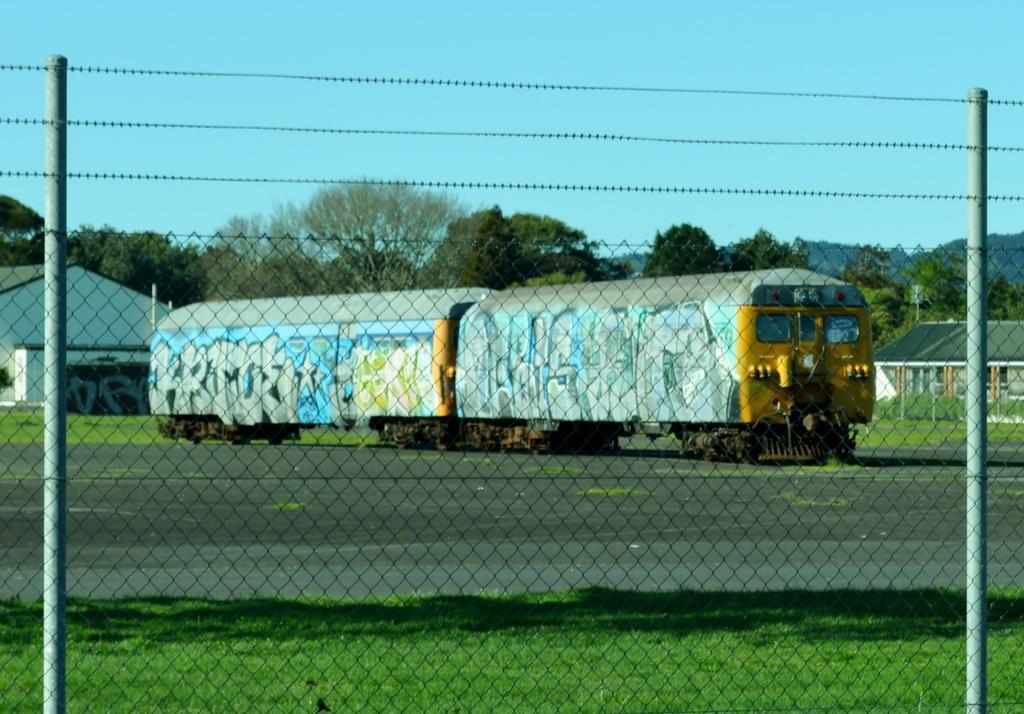How would you summarize this image in a sentence or two? In this image there is a train on the road. Behind there is a house near grassland. Right side there is a house, before it there are few plants on grassland. Front side of image there is a fence, behind there is a grassland. 